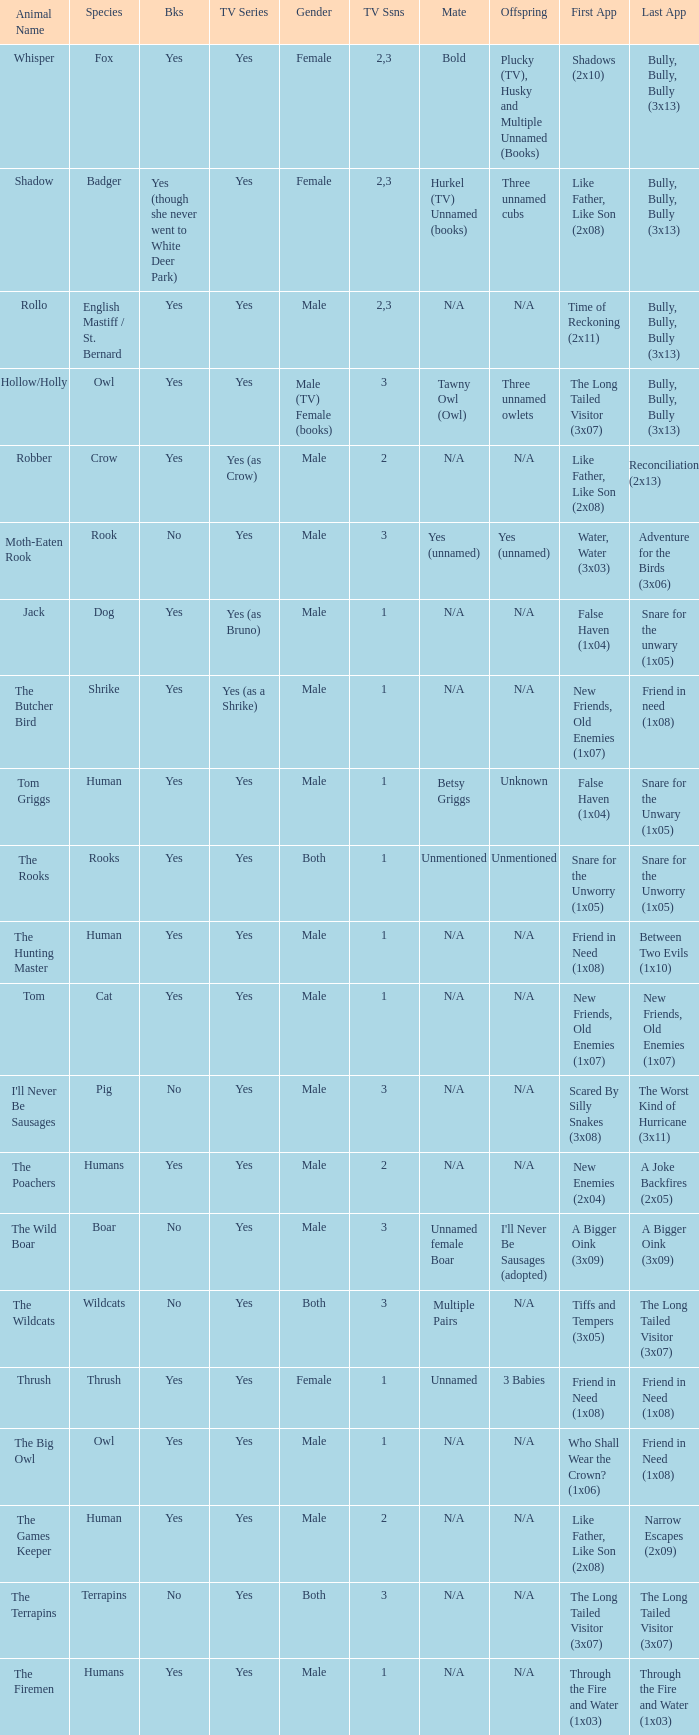What show has a boar? Yes. 